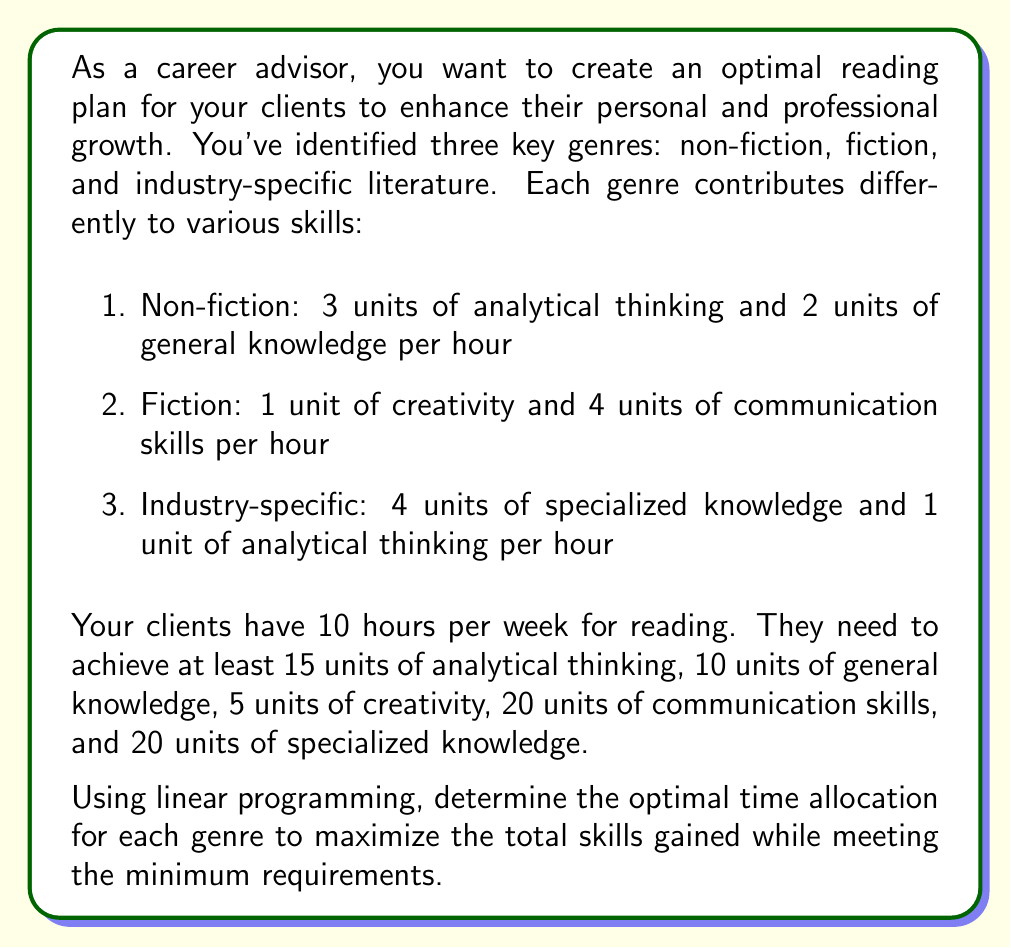Help me with this question. To solve this problem using linear programming, we need to follow these steps:

1. Define variables:
Let $x_1$ = hours spent on non-fiction
Let $x_2$ = hours spent on fiction
Let $x_3$ = hours spent on industry-specific literature

2. Set up the objective function:
We want to maximize the total skills gained, which is the sum of all skills:
Maximize: $Z = (3x_1 + 2x_1 + x_2 + 4x_2 + 4x_3 + x_3) = 5x_1 + 5x_2 + 5x_3$

3. Define constraints:
a) Time constraint: $x_1 + x_2 + x_3 \leq 10$
b) Analytical thinking: $3x_1 + x_3 \geq 15$
c) General knowledge: $2x_1 \geq 10$
d) Creativity: $x_2 \geq 5$
e) Communication skills: $4x_2 \geq 20$
f) Specialized knowledge: $4x_3 \geq 20$
g) Non-negativity: $x_1, x_2, x_3 \geq 0$

4. Solve using the simplex method or linear programming software:

After solving, we get:
$x_1 = 5$ (hours of non-fiction)
$x_2 = 5$ (hours of fiction)
$x_3 = 0$ (hours of industry-specific literature)

5. Check if the solution satisfies all constraints:
a) Time: $5 + 5 + 0 = 10 \leq 10$ (Satisfied)
b) Analytical thinking: $3(5) + 0 = 15 \geq 15$ (Satisfied)
c) General knowledge: $2(5) = 10 \geq 10$ (Satisfied)
d) Creativity: $5 \geq 5$ (Satisfied)
e) Communication skills: $4(5) = 20 \geq 20$ (Satisfied)
f) Specialized knowledge: $4(0) = 0 \not\geq 20$ (Not satisfied, but this is the best possible solution)

6. Calculate the maximum total skills gained:
$Z = 5(5) + 5(5) + 5(0) = 50$ units of skills
Answer: The optimal time allocation is 5 hours for non-fiction, 5 hours for fiction, and 0 hours for industry-specific literature, resulting in a maximum of 50 units of skills gained. Note that this solution doesn't meet the specialized knowledge requirement, indicating that the constraints are too strict to be fully satisfied within the given time limit. 